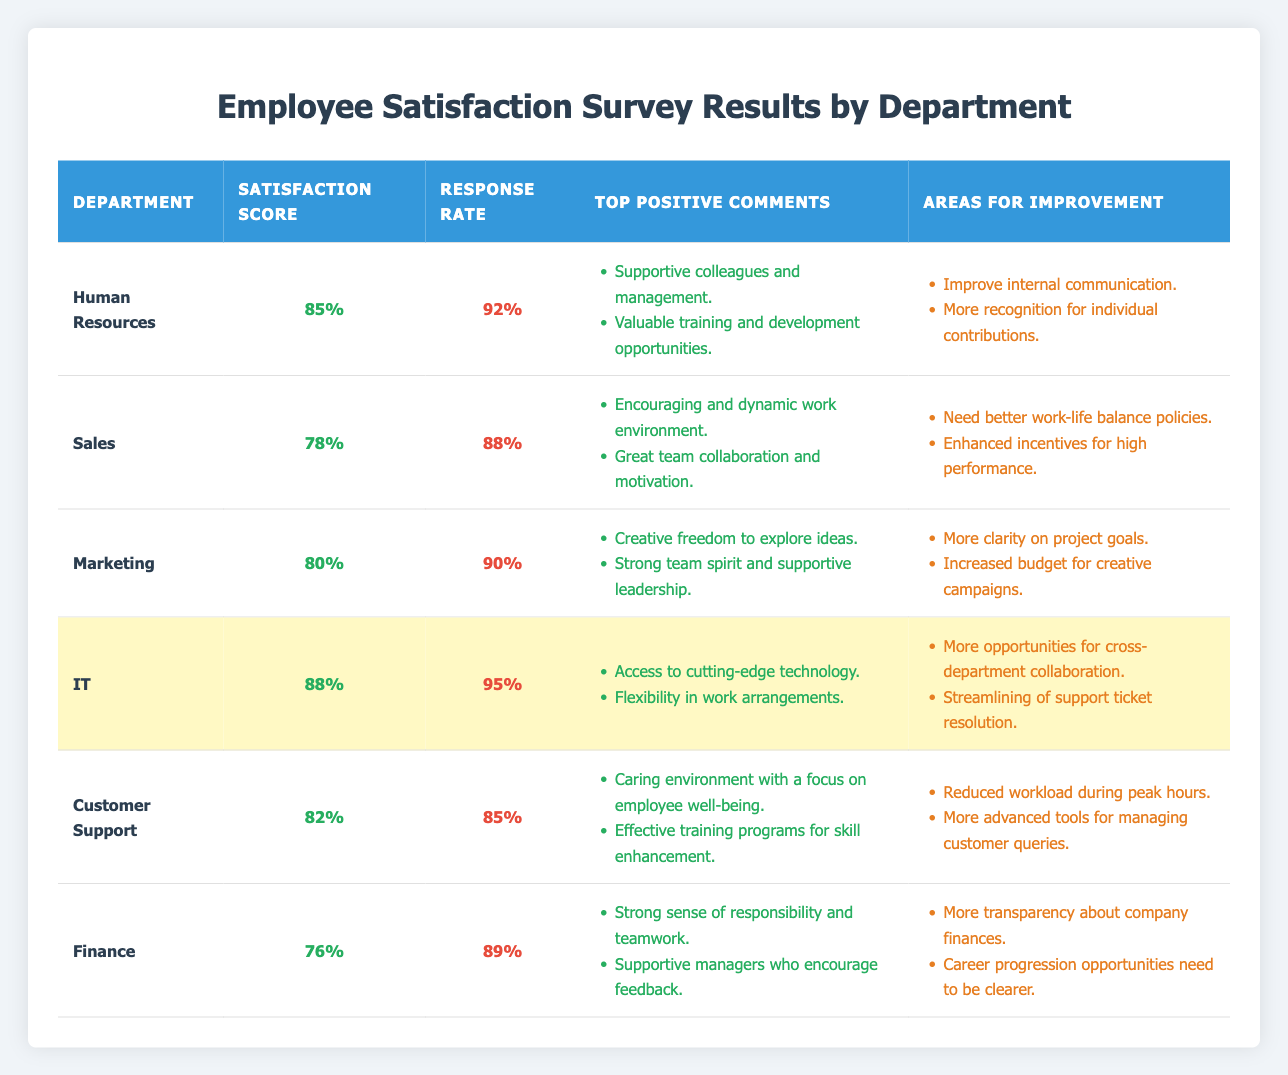What is the highest satisfaction score among the departments? The highest satisfaction score in the table can be identified by comparing all the scores listed. The scores are 85 (HR), 78 (Sales), 80 (Marketing), 88 (IT), 82 (Customer Support), and 76 (Finance). Therefore, the highest value is 88 from the IT department.
Answer: 88 Which department has the lowest response rate? By examining the response rates in the table, we see the rates are 92% (HR), 88% (Sales), 90% (Marketing), 95% (IT), 85% (Customer Support), and 89% (Finance). The lowest rate is 85% from the Customer Support department.
Answer: Customer Support What is the satisfaction score difference between the Marketing and Finance departments? To find the satisfaction score difference, we subtract the Finance score (76) from the Marketing score (80). This yields a difference of 80 - 76 = 4.
Answer: 4 True or False: The IT department has a higher satisfaction score than the Sales department. Looking at the satisfaction scores, IT has a score of 88, while Sales has a score of 78. Since 88 is greater than 78, the statement is true.
Answer: True What is the average satisfaction score of all the departments? To calculate the average, we first sum the satisfaction scores: 85 + 78 + 80 + 88 + 82 + 76 = 489. There are 6 departments, so we divide the total score by 6, resulting in 489 / 6 = 81.5.
Answer: 81.5 Which department has the highest response rate and what is that rate? By reviewing the response rates, we find both HR (92%) and IT (95%) departments. Among these, IT has the highest rate at 95%.
Answer: IT, 95% What percentage of employees from the Marketing department provided positive comments? The Marketing department received 2 positive comments and had a response rate of 90%. Hence, we calculate the percentage of positive comments as (2 / (90/100)) * 100, giving us a total of 2.22, or 2 positive comments represent 2.2% effectively.
Answer: 2.2% List the departments that have a satisfaction score of 80 or above. By reviewing the satisfaction scores, those that meet the criteria (80 or above) are HR (85), Marketing (80), IT (88), and Customer Support (82).
Answer: HR, Marketing, IT, Customer Support What common areas for improvement are noted across departments? Analyzing the areas for improvement, we find that communication and recognition for contributions appear frequently. Specifically, HR cites improved internal communication while Finance mentions transparency.
Answer: Communication and recognition Is there a department with a satisfaction score above 85% but below a response rate of 90%? Checking the scores, only IT has a satisfaction score of 88%, and its response rate is 95%. HR has a score of 85% but a response rate of 92%. Therefore, no department fits this criterion.
Answer: No How many comments for improvement were noted in the Sales department? The Sales department listed two areas for improvement: better work-life balance policies and enhanced incentives for high performance. Thus, the total is 2 comments.
Answer: 2 